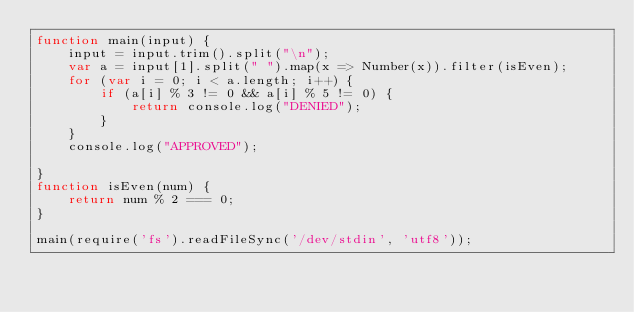Convert code to text. <code><loc_0><loc_0><loc_500><loc_500><_JavaScript_>function main(input) {
    input = input.trim().split("\n");
    var a = input[1].split(" ").map(x => Number(x)).filter(isEven);
    for (var i = 0; i < a.length; i++) {
        if (a[i] % 3 != 0 && a[i] % 5 != 0) {
            return console.log("DENIED");
        } 
    }
    console.log("APPROVED");

}
function isEven(num) {
    return num % 2 === 0;
}

main(require('fs').readFileSync('/dev/stdin', 'utf8'));</code> 